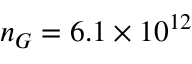Convert formula to latex. <formula><loc_0><loc_0><loc_500><loc_500>n _ { G } = 6 . 1 \times 1 0 ^ { 1 2 }</formula> 